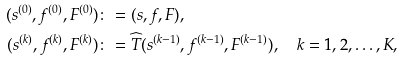<formula> <loc_0><loc_0><loc_500><loc_500>( s ^ { ( 0 ) } , f ^ { ( 0 ) } , F ^ { ( 0 ) } ) & \colon = ( s , f , F ) , \\ ( s ^ { ( k ) } , f ^ { ( k ) } , F ^ { ( k ) } ) & \colon = \widehat { T } ( s ^ { ( k - 1 ) } , f ^ { ( k - 1 ) } , F ^ { ( k - 1 ) } ) , \quad k = 1 , 2 , \dots , K ,</formula> 